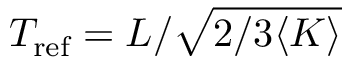<formula> <loc_0><loc_0><loc_500><loc_500>T _ { r e f } = L / \sqrt { 2 / 3 \langle K \rangle }</formula> 